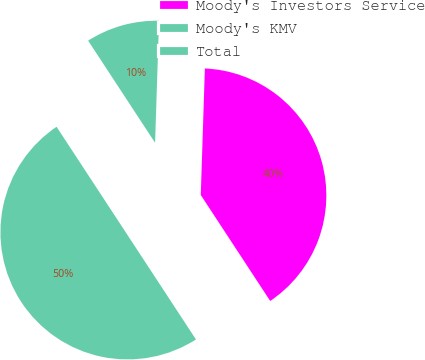Convert chart. <chart><loc_0><loc_0><loc_500><loc_500><pie_chart><fcel>Moody's Investors Service<fcel>Moody's KMV<fcel>Total<nl><fcel>40.25%<fcel>9.75%<fcel>50.0%<nl></chart> 